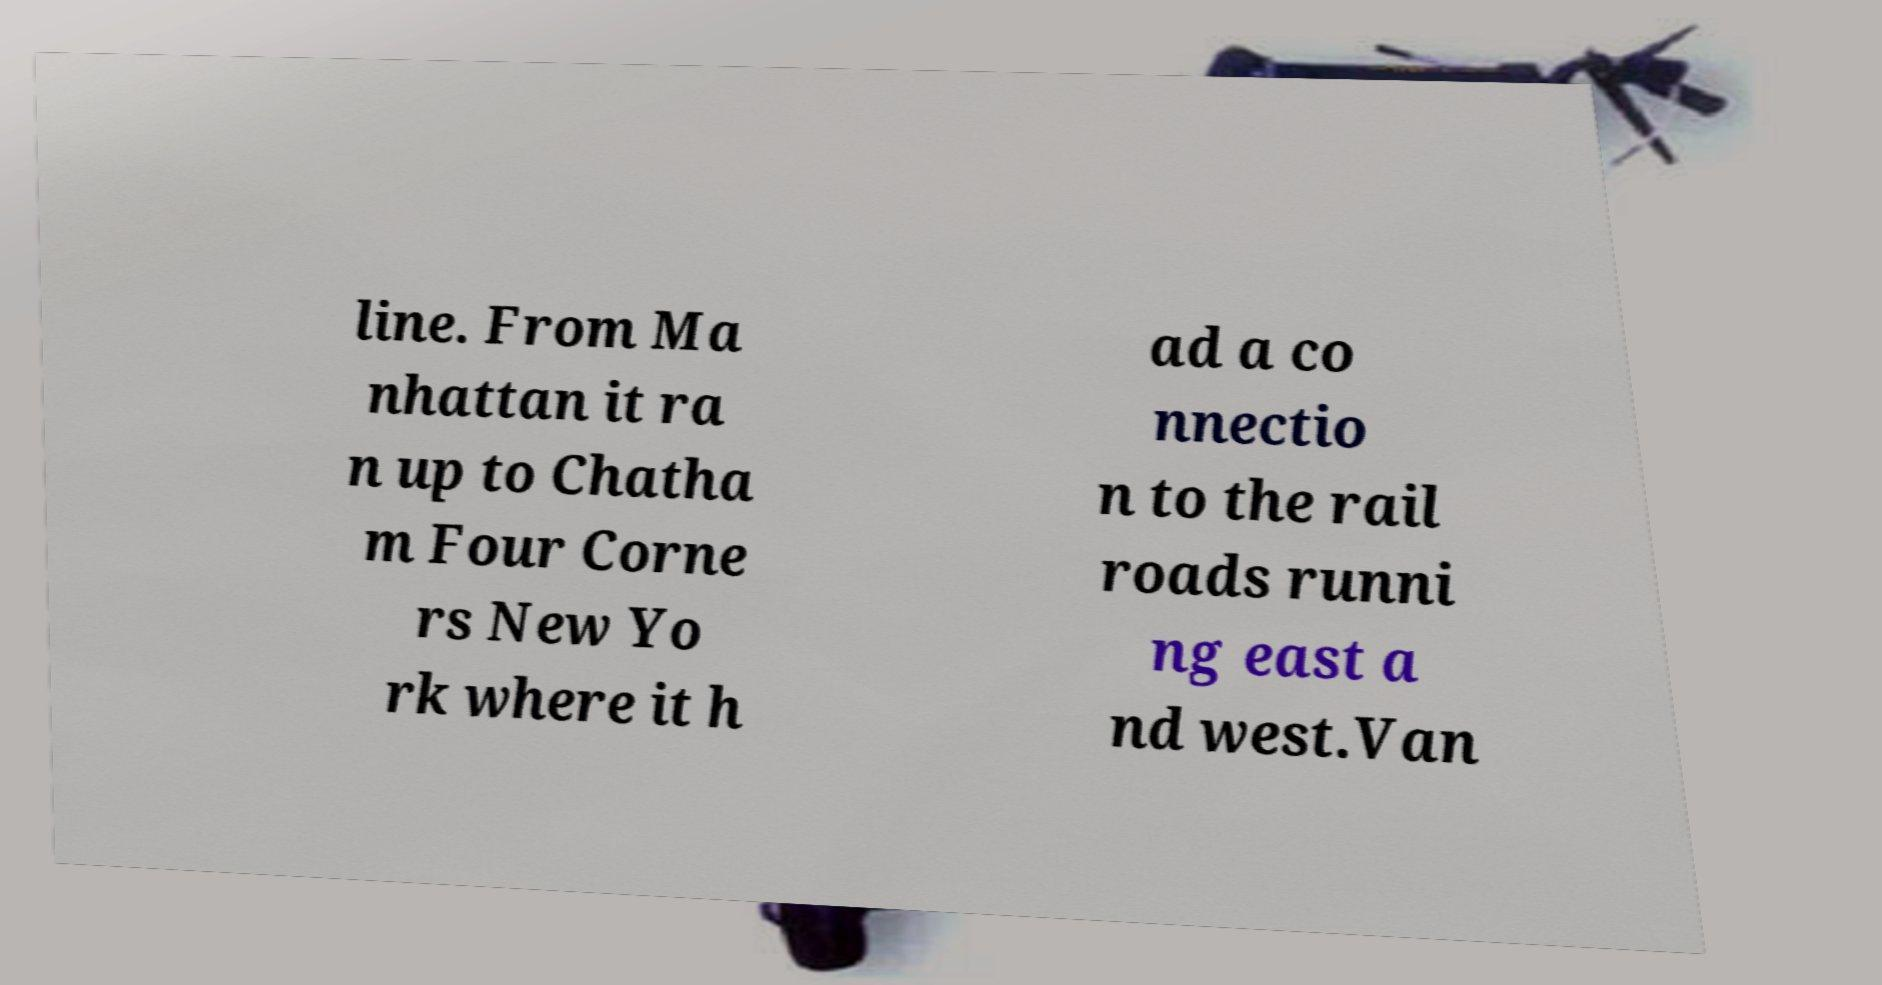Please identify and transcribe the text found in this image. line. From Ma nhattan it ra n up to Chatha m Four Corne rs New Yo rk where it h ad a co nnectio n to the rail roads runni ng east a nd west.Van 